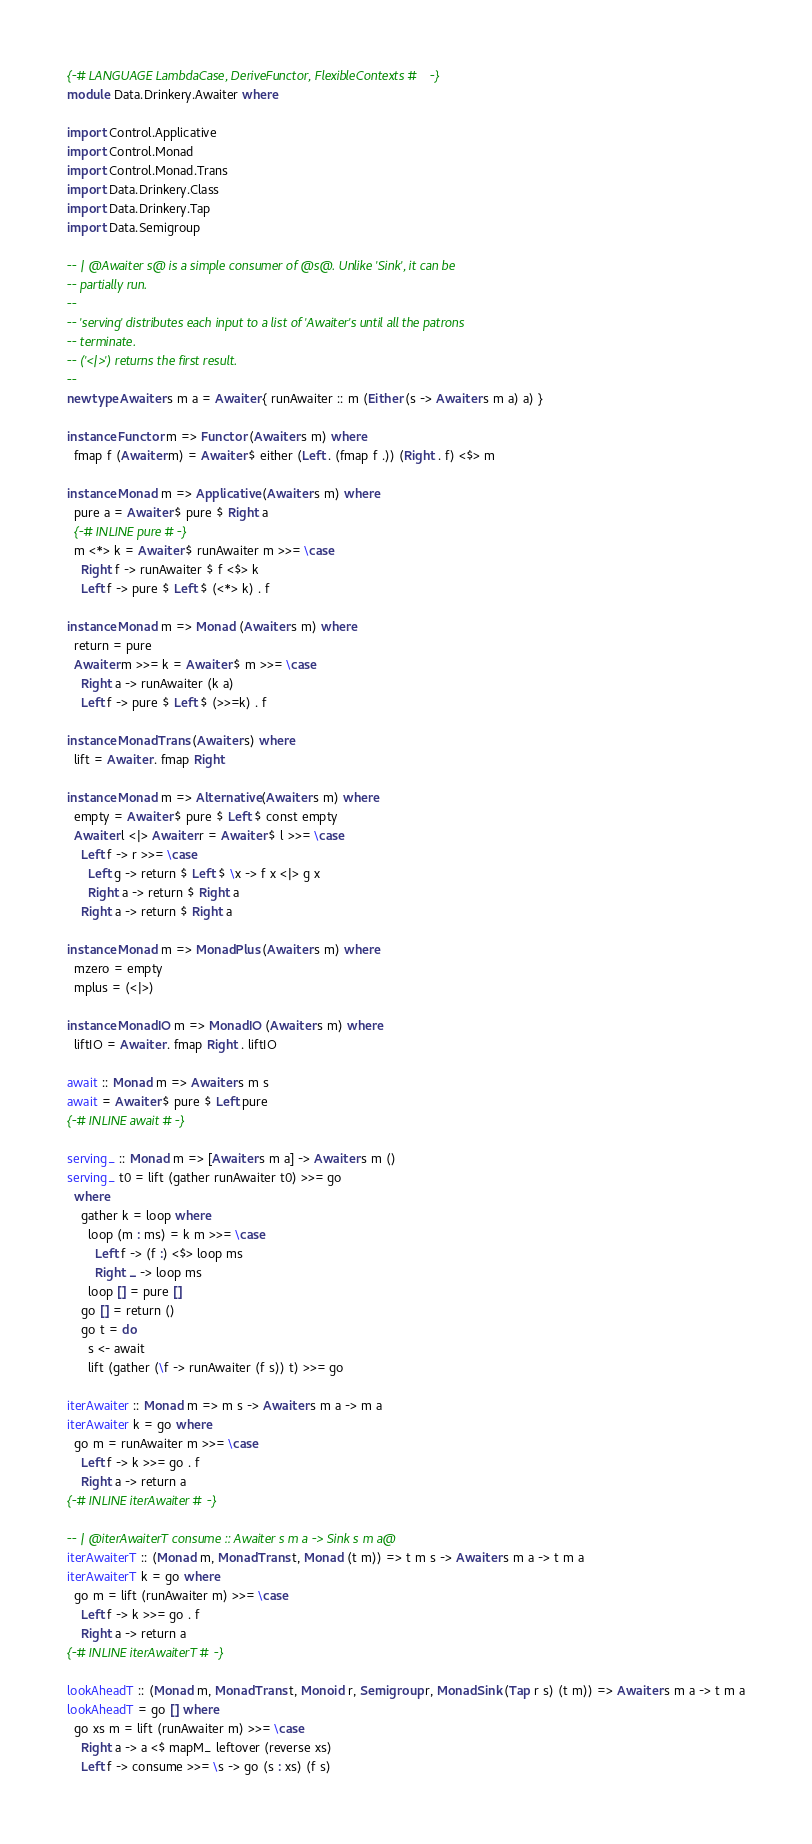Convert code to text. <code><loc_0><loc_0><loc_500><loc_500><_Haskell_>{-# LANGUAGE LambdaCase, DeriveFunctor, FlexibleContexts #-}
module Data.Drinkery.Awaiter where

import Control.Applicative
import Control.Monad
import Control.Monad.Trans
import Data.Drinkery.Class
import Data.Drinkery.Tap
import Data.Semigroup

-- | @Awaiter s@ is a simple consumer of @s@. Unlike 'Sink', it can be
-- partially run.
--
-- 'serving' distributes each input to a list of 'Awaiter's until all the patrons
-- terminate.
-- ('<|>') returns the first result.
--
newtype Awaiter s m a = Awaiter { runAwaiter :: m (Either (s -> Awaiter s m a) a) }

instance Functor m => Functor (Awaiter s m) where
  fmap f (Awaiter m) = Awaiter $ either (Left . (fmap f .)) (Right . f) <$> m

instance Monad m => Applicative (Awaiter s m) where
  pure a = Awaiter $ pure $ Right a
  {-# INLINE pure #-}
  m <*> k = Awaiter $ runAwaiter m >>= \case
    Right f -> runAwaiter $ f <$> k
    Left f -> pure $ Left $ (<*> k) . f

instance Monad m => Monad (Awaiter s m) where
  return = pure
  Awaiter m >>= k = Awaiter $ m >>= \case
    Right a -> runAwaiter (k a)
    Left f -> pure $ Left $ (>>=k) . f

instance MonadTrans (Awaiter s) where
  lift = Awaiter . fmap Right

instance Monad m => Alternative (Awaiter s m) where
  empty = Awaiter $ pure $ Left $ const empty
  Awaiter l <|> Awaiter r = Awaiter $ l >>= \case
    Left f -> r >>= \case
      Left g -> return $ Left $ \x -> f x <|> g x
      Right a -> return $ Right a
    Right a -> return $ Right a

instance Monad m => MonadPlus (Awaiter s m) where
  mzero = empty
  mplus = (<|>)

instance MonadIO m => MonadIO (Awaiter s m) where
  liftIO = Awaiter . fmap Right . liftIO

await :: Monad m => Awaiter s m s
await = Awaiter $ pure $ Left pure
{-# INLINE await #-}

serving_ :: Monad m => [Awaiter s m a] -> Awaiter s m ()
serving_ t0 = lift (gather runAwaiter t0) >>= go
  where
    gather k = loop where
      loop (m : ms) = k m >>= \case
        Left f -> (f :) <$> loop ms
        Right _ -> loop ms
      loop [] = pure []
    go [] = return ()
    go t = do
      s <- await
      lift (gather (\f -> runAwaiter (f s)) t) >>= go

iterAwaiter :: Monad m => m s -> Awaiter s m a -> m a
iterAwaiter k = go where
  go m = runAwaiter m >>= \case
    Left f -> k >>= go . f
    Right a -> return a
{-# INLINE iterAwaiter #-}

-- | @iterAwaiterT consume :: Awaiter s m a -> Sink s m a@
iterAwaiterT :: (Monad m, MonadTrans t, Monad (t m)) => t m s -> Awaiter s m a -> t m a
iterAwaiterT k = go where
  go m = lift (runAwaiter m) >>= \case
    Left f -> k >>= go . f
    Right a -> return a
{-# INLINE iterAwaiterT #-}

lookAheadT :: (Monad m, MonadTrans t, Monoid r, Semigroup r, MonadSink (Tap r s) (t m)) => Awaiter s m a -> t m a
lookAheadT = go [] where
  go xs m = lift (runAwaiter m) >>= \case
    Right a -> a <$ mapM_ leftover (reverse xs)
    Left f -> consume >>= \s -> go (s : xs) (f s)
</code> 